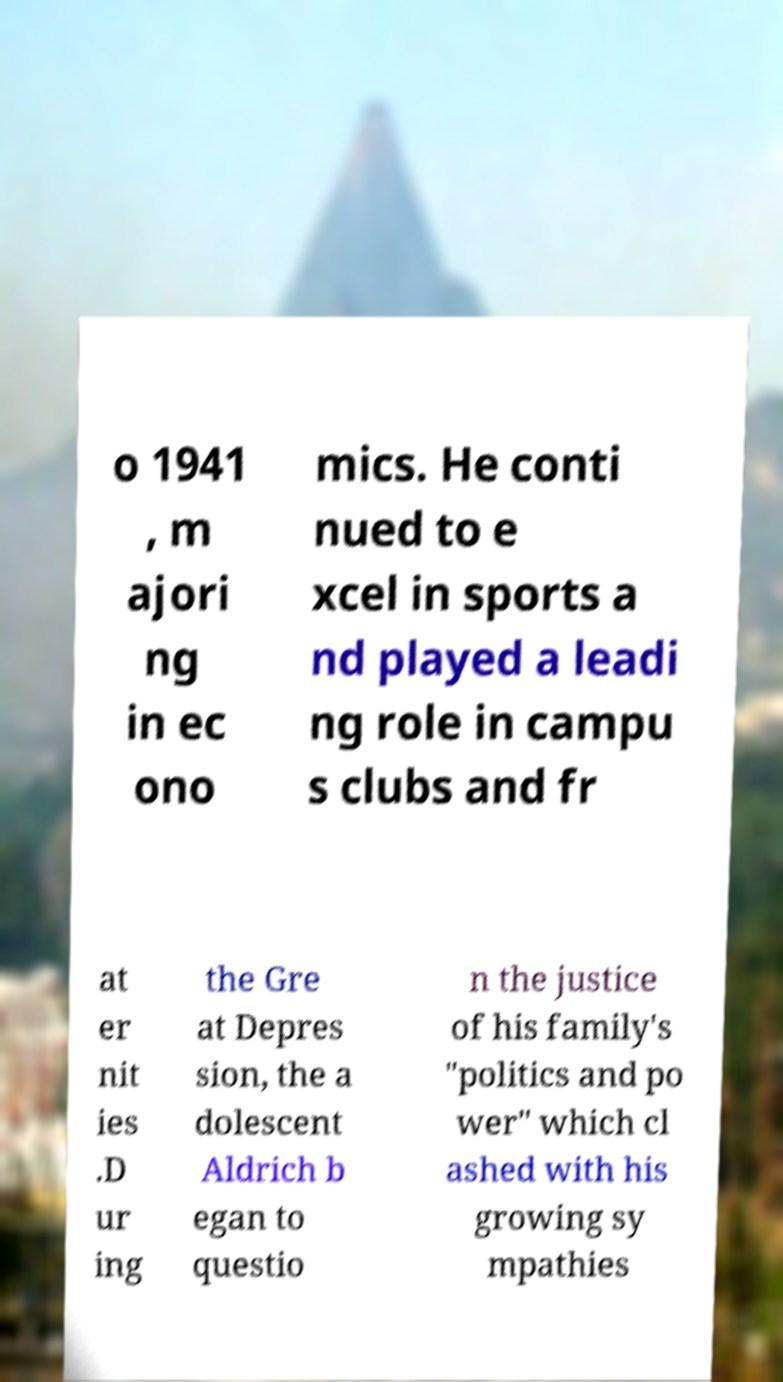Please identify and transcribe the text found in this image. o 1941 , m ajori ng in ec ono mics. He conti nued to e xcel in sports a nd played a leadi ng role in campu s clubs and fr at er nit ies .D ur ing the Gre at Depres sion, the a dolescent Aldrich b egan to questio n the justice of his family's "politics and po wer" which cl ashed with his growing sy mpathies 